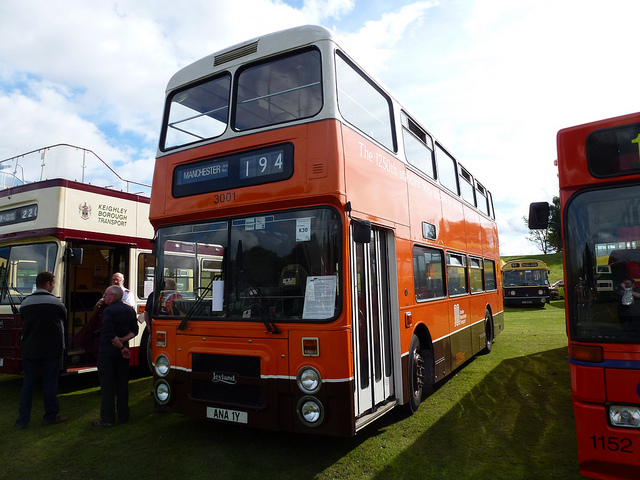Please transcribe the text in this image. 194 MANCHESTER 3001 1152 BOROUGH 221 1 1Y ANA KENGHLEY The 